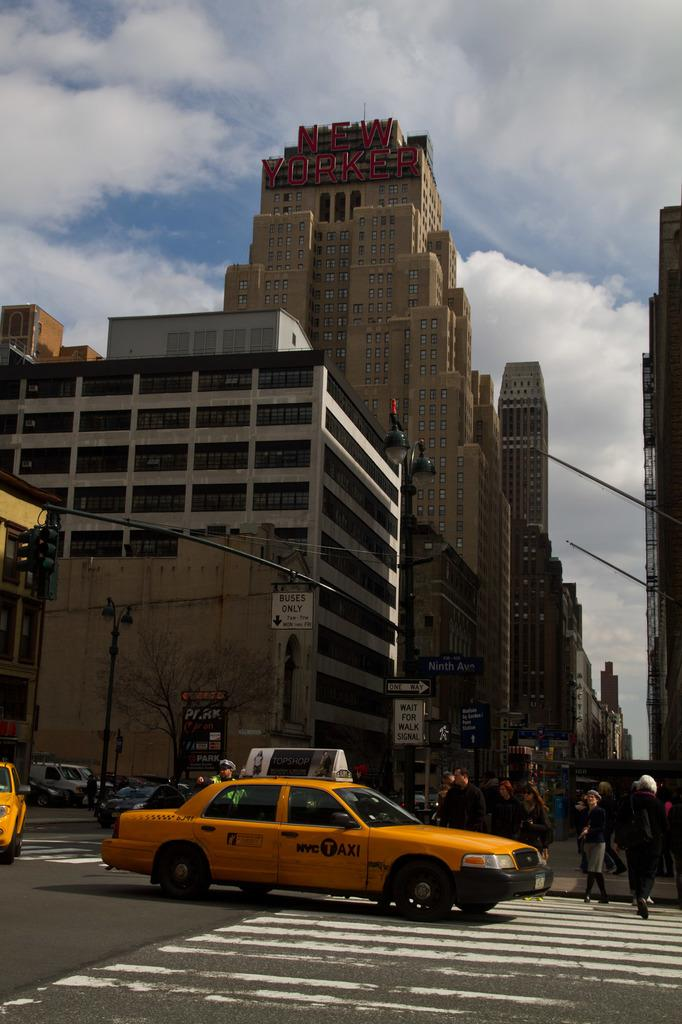<image>
Present a compact description of the photo's key features. A sign on the curb says "wait for walk signal" at this New York City intersection 